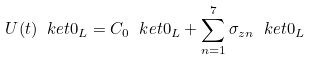<formula> <loc_0><loc_0><loc_500><loc_500>U ( t ) \ k e t { 0 _ { L } } = C _ { 0 } \ k e t { 0 _ { L } } + \sum _ { n = 1 } ^ { 7 } \sigma _ { z n } \ k e t { 0 _ { L } }</formula> 